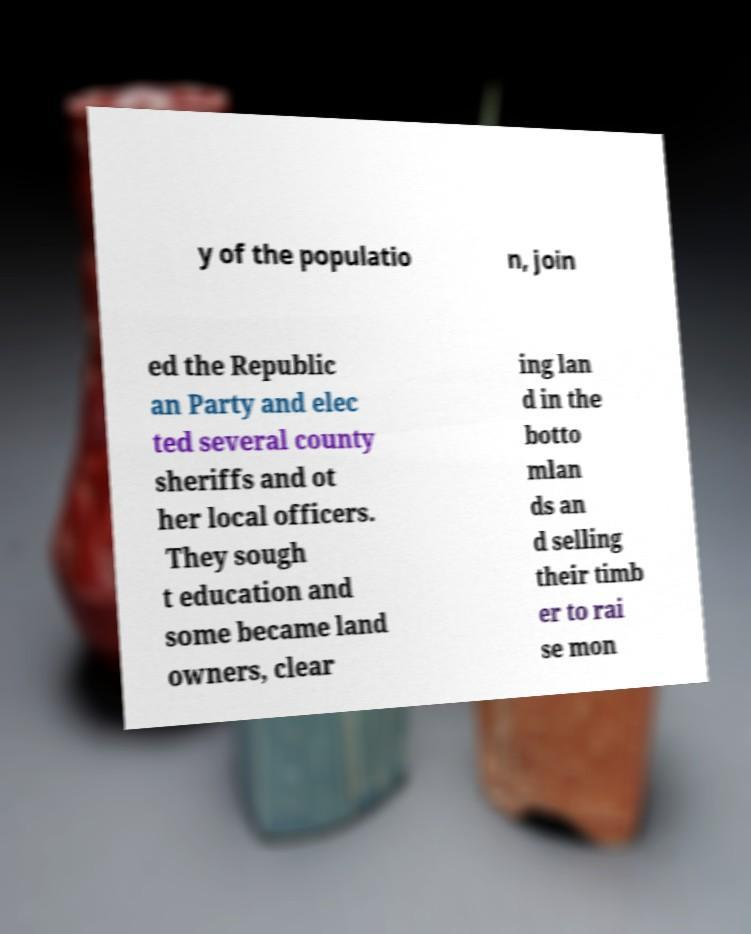Please read and relay the text visible in this image. What does it say? y of the populatio n, join ed the Republic an Party and elec ted several county sheriffs and ot her local officers. They sough t education and some became land owners, clear ing lan d in the botto mlan ds an d selling their timb er to rai se mon 